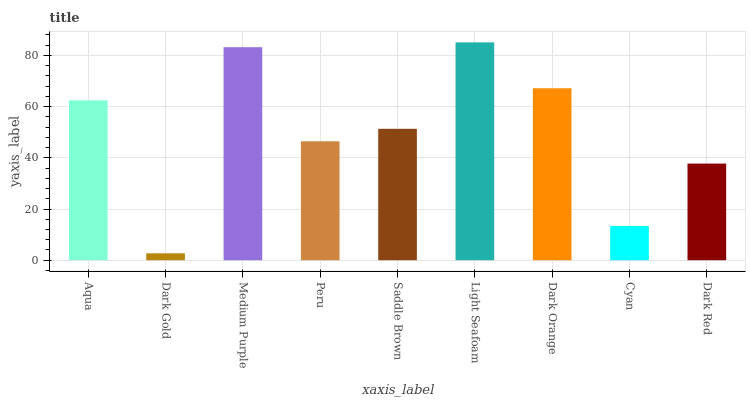Is Dark Gold the minimum?
Answer yes or no. Yes. Is Light Seafoam the maximum?
Answer yes or no. Yes. Is Medium Purple the minimum?
Answer yes or no. No. Is Medium Purple the maximum?
Answer yes or no. No. Is Medium Purple greater than Dark Gold?
Answer yes or no. Yes. Is Dark Gold less than Medium Purple?
Answer yes or no. Yes. Is Dark Gold greater than Medium Purple?
Answer yes or no. No. Is Medium Purple less than Dark Gold?
Answer yes or no. No. Is Saddle Brown the high median?
Answer yes or no. Yes. Is Saddle Brown the low median?
Answer yes or no. Yes. Is Aqua the high median?
Answer yes or no. No. Is Light Seafoam the low median?
Answer yes or no. No. 